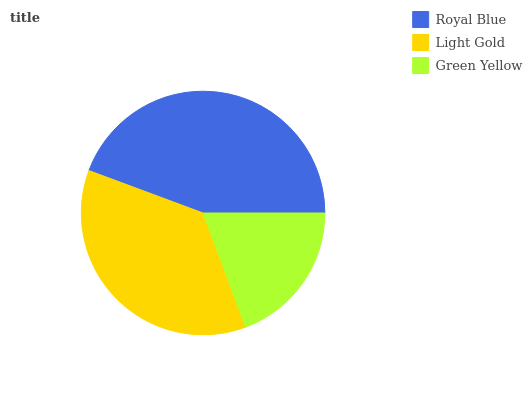Is Green Yellow the minimum?
Answer yes or no. Yes. Is Royal Blue the maximum?
Answer yes or no. Yes. Is Light Gold the minimum?
Answer yes or no. No. Is Light Gold the maximum?
Answer yes or no. No. Is Royal Blue greater than Light Gold?
Answer yes or no. Yes. Is Light Gold less than Royal Blue?
Answer yes or no. Yes. Is Light Gold greater than Royal Blue?
Answer yes or no. No. Is Royal Blue less than Light Gold?
Answer yes or no. No. Is Light Gold the high median?
Answer yes or no. Yes. Is Light Gold the low median?
Answer yes or no. Yes. Is Royal Blue the high median?
Answer yes or no. No. Is Green Yellow the low median?
Answer yes or no. No. 